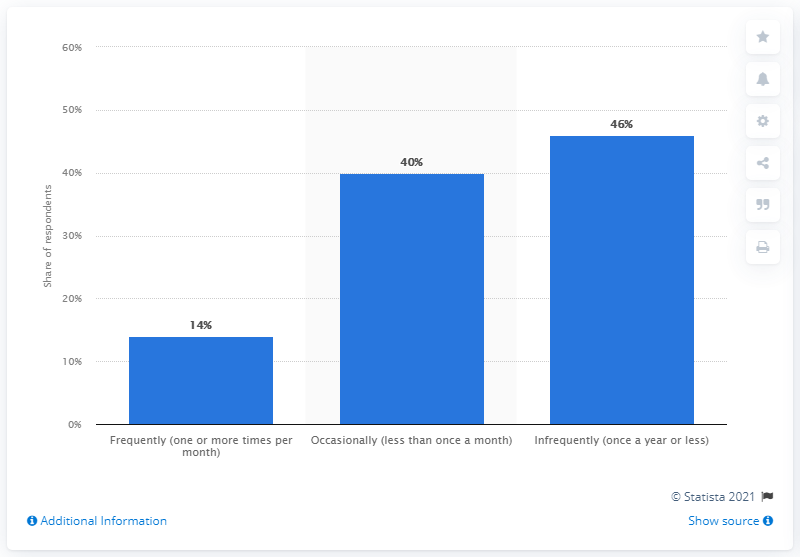Identify some key points in this picture. The difference between the highest bar and the lowest bar in percent is 32%. The highest bar value is 46. 